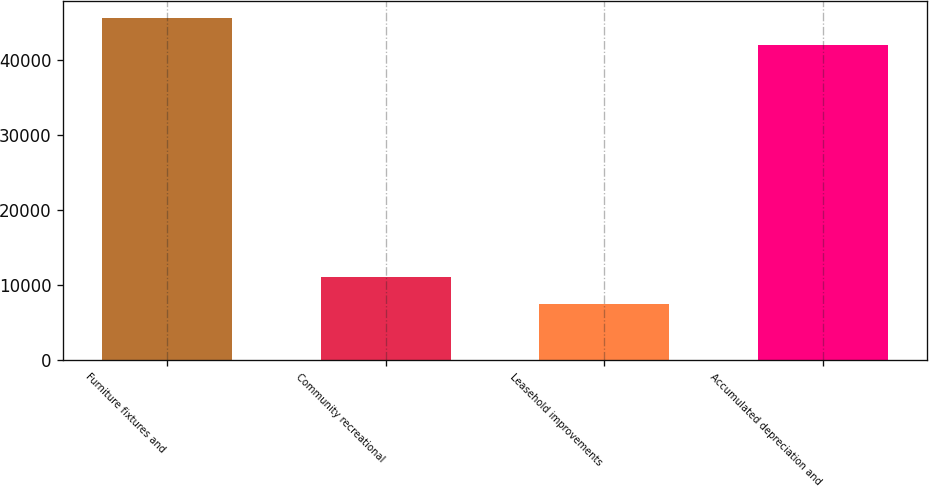Convert chart. <chart><loc_0><loc_0><loc_500><loc_500><bar_chart><fcel>Furniture fixtures and<fcel>Community recreational<fcel>Leasehold improvements<fcel>Accumulated depreciation and<nl><fcel>45517.2<fcel>11108.2<fcel>7510<fcel>41919<nl></chart> 